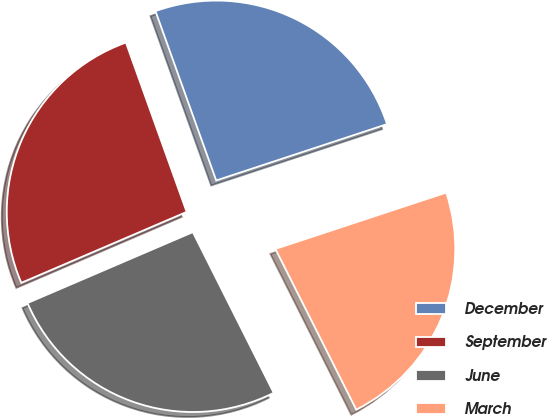Convert chart. <chart><loc_0><loc_0><loc_500><loc_500><pie_chart><fcel>December<fcel>September<fcel>June<fcel>March<nl><fcel>25.41%<fcel>25.97%<fcel>25.97%<fcel>22.65%<nl></chart> 